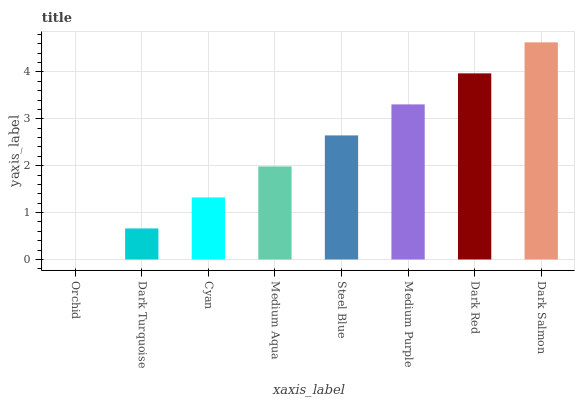Is Orchid the minimum?
Answer yes or no. Yes. Is Dark Salmon the maximum?
Answer yes or no. Yes. Is Dark Turquoise the minimum?
Answer yes or no. No. Is Dark Turquoise the maximum?
Answer yes or no. No. Is Dark Turquoise greater than Orchid?
Answer yes or no. Yes. Is Orchid less than Dark Turquoise?
Answer yes or no. Yes. Is Orchid greater than Dark Turquoise?
Answer yes or no. No. Is Dark Turquoise less than Orchid?
Answer yes or no. No. Is Steel Blue the high median?
Answer yes or no. Yes. Is Medium Aqua the low median?
Answer yes or no. Yes. Is Medium Aqua the high median?
Answer yes or no. No. Is Dark Turquoise the low median?
Answer yes or no. No. 